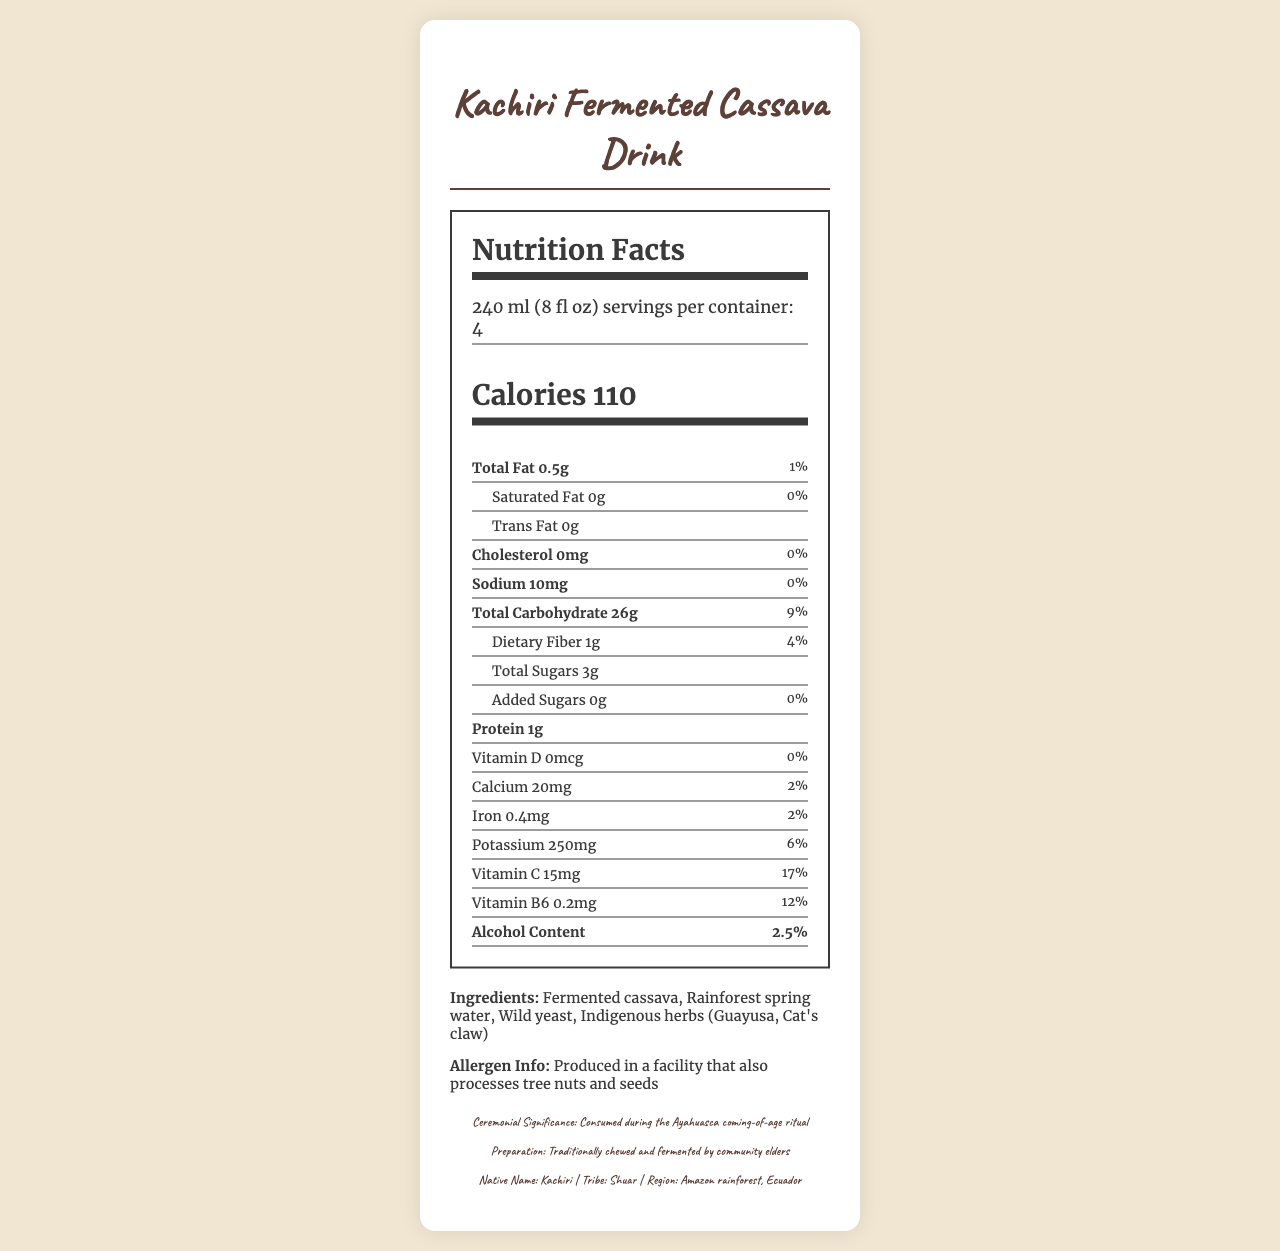what is the product name? The document clearly lists "Kachiri Fermented Cassava Drink" as the product name at the top.
Answer: Kachiri Fermented Cassava Drink what is the serving size of the beverage? The serving size of the beverage is specified as "240 ml (8 fl oz)" in the document.
Answer: 240 ml (8 fl oz) how many servings are there per container? The document mentions that there are 4 servings per container.
Answer: 4 what's the total fat content per serving? The document specifies the total fat content as "0.5g" per serving.
Answer: 0.5g what tribe traditionally consumes this beverage? The document states that the Shuar tribe traditionally consumes this beverage.
Answer: Shuar how much cholesterol is in each serving? The document indicates that each serving contains "0mg" of cholesterol.
Answer: 0mg how much dietary fiber does one serving contain? According to the document, one serving contains "1g" of dietary fiber.
Answer: 1g what is the main ingredient in the Kachiri Fermented Cassava Drink? A. Fermented cassava B. Rainforest spring water C. Wild yeast The main ingredient listed in the document is "Fermented cassava."
Answer: A how much vitamin C is present in each serving? A. 10mg B. 15mg C. 20mg D. 25mg According to the document, each serving contains "15mg" of vitamin C.
Answer: B what is the alcohol content of the beverage? A. 1.5% B. 2.0% C. 2.5% D. 3.0% The beverage has an alcohol content of "2.5%" as mentioned in the document.
Answer: C does this beverage contain trans fat? The document specifies that each serving contains "0g" of trans fat.
Answer: No are there any added sugars in the beverage? The document indicates that there are "0g" of added sugars in the beverage.
Answer: No is the Kachiri Fermented Cassava Drink high in protein? Each serving contains only "1g" of protein, which is relatively low.
Answer: No does the beverage include any allergen information? The document states that it is produced in a facility that also processes tree nuts and seeds.
Answer: Yes what is the ceremonial significance of this beverage? The beverage is consumed during the Ayahuasca coming-of-age ritual as mentioned in the document.
Answer: Consumed during the Ayahuasca coming-of-age ritual describe the preparation method of the Kachiri drink. The document specifies that the drink is traditionally chewed and fermented by community elders.
Answer: Traditionally chewed and fermented by community elders how much iron is in a single serving of this beverage? The document states that there is "0.4mg" of iron in each serving.
Answer: 0.4mg which vitamins are listed in the nutritional breakdown? The document lists Vitamin D, Vitamin C, and Vitamin B6 in the nutritional breakdown.
Answer: Vitamin D, Vitamin C, Vitamin B6 what is the primary region where this beverage is consumed? The document mentions that the tribe consuming this beverage is from the Amazon rainforest in Ecuador.
Answer: Amazon rainforest, Ecuador how many ingredients are in the Kachiri Fermented Cassava Drink? The document lists "Fermented cassava, Rainforest spring water, Wild yeast, Indigenous herbs (Guayusa, Cat's claw)" which totals four main ingredients.
Answer: Four main ingredients what is the significance of the ingredient wild yeast? The document does not provide specific information about the significance of wild yeast.
Answer: Cannot be determined provide a summary of the document. The document mainly focuses on the nutritional breakdown, cultural significance, and specific details about the preparation and ingredients of the Kachiri Fermented Cassava Drink.
Answer: The document provides detailed information about the Kachiri Fermented Cassava Drink, including its nutritional facts, ingredients, allergen information, ceremonial significance, and preparation method. The drink, consumed during Ayahuasca coming-of-age rituals by the Shuar tribe of the Amazon rainforest in Ecuador, has a serving size of 240ml with 110 calories per serving. It contains various nutrients and a 2.5% alcohol content. 